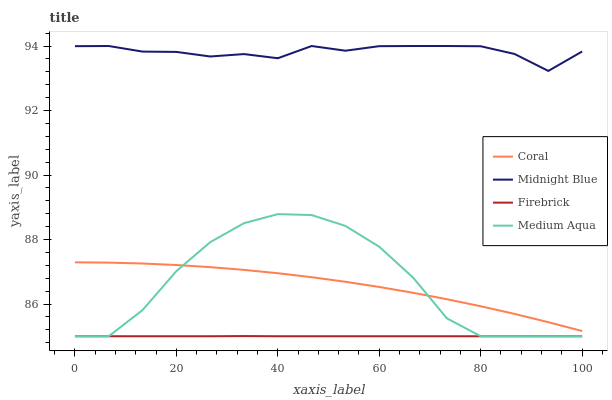Does Firebrick have the minimum area under the curve?
Answer yes or no. Yes. Does Midnight Blue have the maximum area under the curve?
Answer yes or no. Yes. Does Coral have the minimum area under the curve?
Answer yes or no. No. Does Coral have the maximum area under the curve?
Answer yes or no. No. Is Firebrick the smoothest?
Answer yes or no. Yes. Is Medium Aqua the roughest?
Answer yes or no. Yes. Is Coral the smoothest?
Answer yes or no. No. Is Coral the roughest?
Answer yes or no. No. Does Firebrick have the lowest value?
Answer yes or no. Yes. Does Coral have the lowest value?
Answer yes or no. No. Does Midnight Blue have the highest value?
Answer yes or no. Yes. Does Coral have the highest value?
Answer yes or no. No. Is Firebrick less than Coral?
Answer yes or no. Yes. Is Midnight Blue greater than Medium Aqua?
Answer yes or no. Yes. Does Medium Aqua intersect Coral?
Answer yes or no. Yes. Is Medium Aqua less than Coral?
Answer yes or no. No. Is Medium Aqua greater than Coral?
Answer yes or no. No. Does Firebrick intersect Coral?
Answer yes or no. No. 